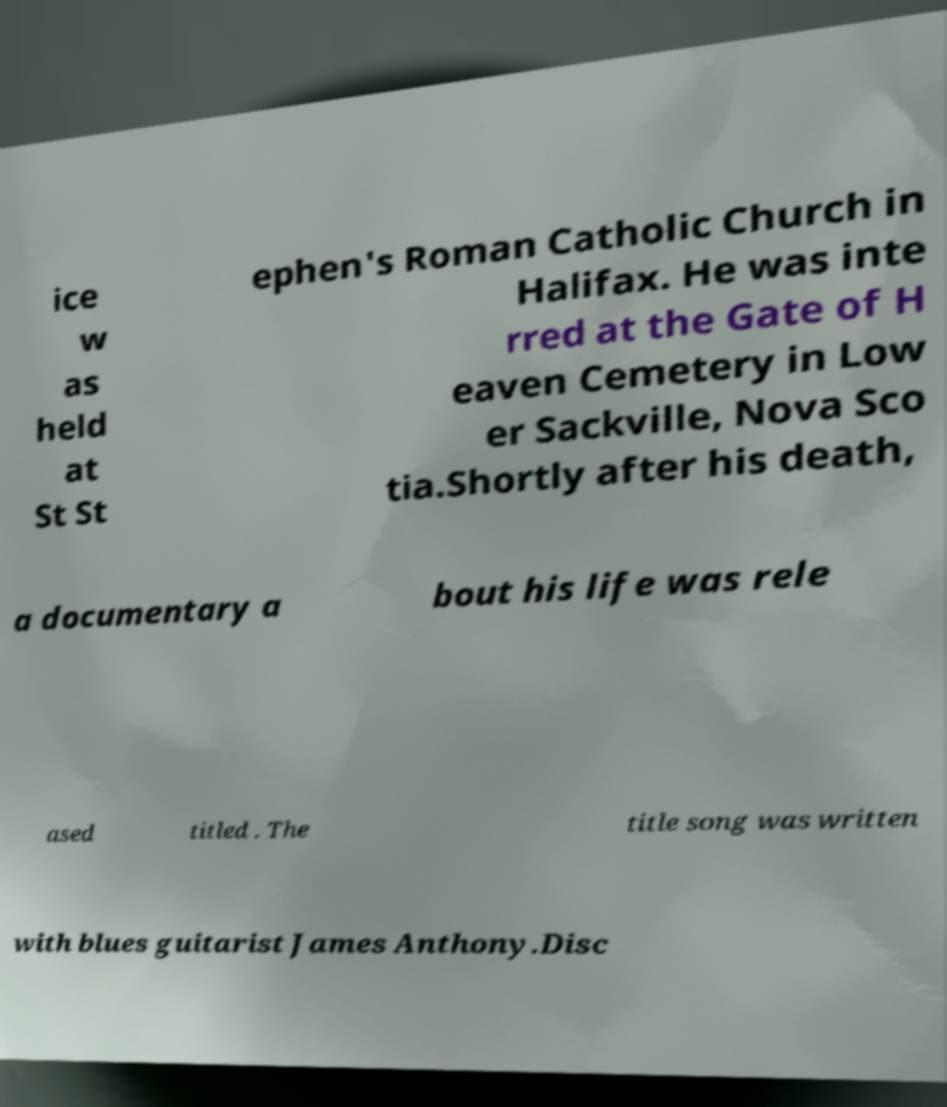What messages or text are displayed in this image? I need them in a readable, typed format. ice w as held at St St ephen's Roman Catholic Church in Halifax. He was inte rred at the Gate of H eaven Cemetery in Low er Sackville, Nova Sco tia.Shortly after his death, a documentary a bout his life was rele ased titled . The title song was written with blues guitarist James Anthony.Disc 